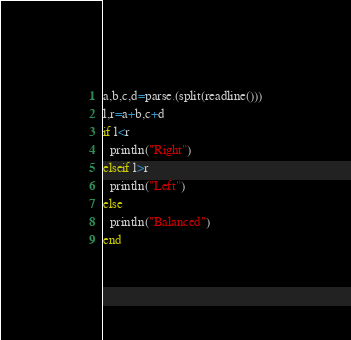<code> <loc_0><loc_0><loc_500><loc_500><_Julia_>a,b,c,d=parse.(split(readline()))
l,r=a+b,c+d
if l<r
  println("Right")
elseif l>r
  println("Left")
else
  println("Balanced")
end</code> 